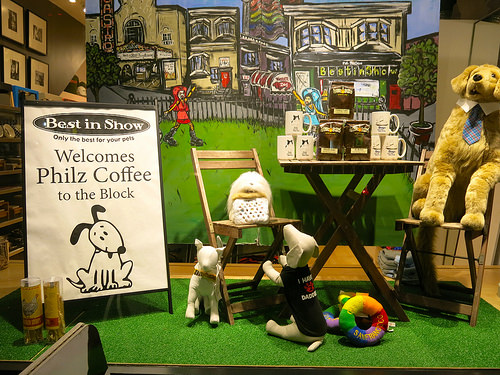<image>
Can you confirm if the stuffed animal is behind the chair? No. The stuffed animal is not behind the chair. From this viewpoint, the stuffed animal appears to be positioned elsewhere in the scene. Where is the dog in relation to the chair? Is it in front of the chair? Yes. The dog is positioned in front of the chair, appearing closer to the camera viewpoint. 